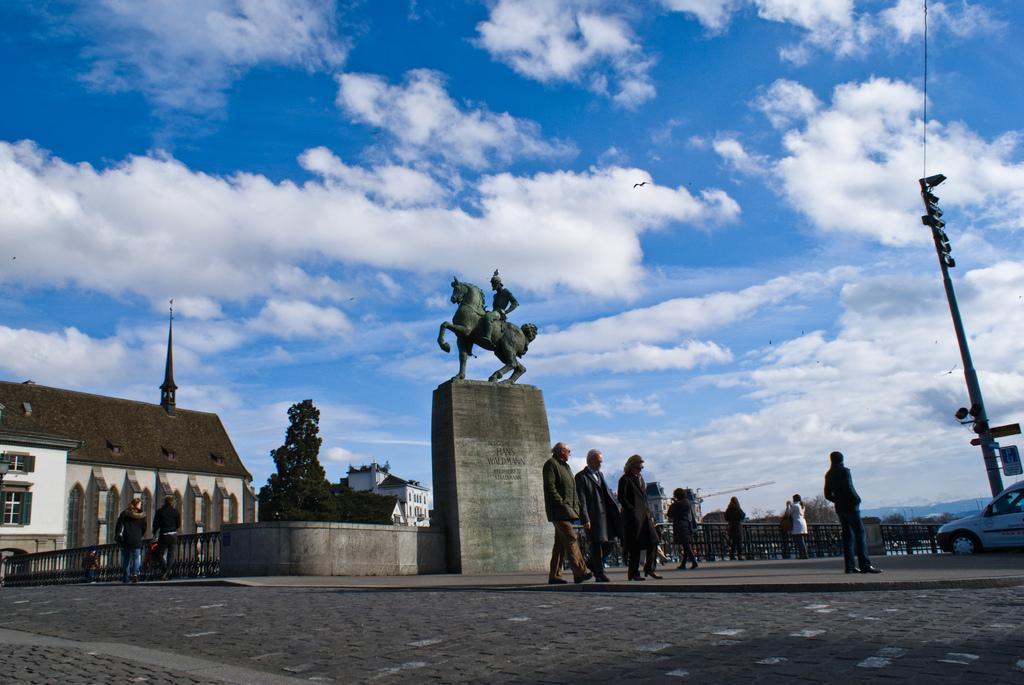Can you describe this image briefly? In this picture we can see the road, some people are walking on the footpath, some people are standing, statue, car, fences, pole, trees, buildings with windows and some objects and in the background we can see the sky with clouds. 